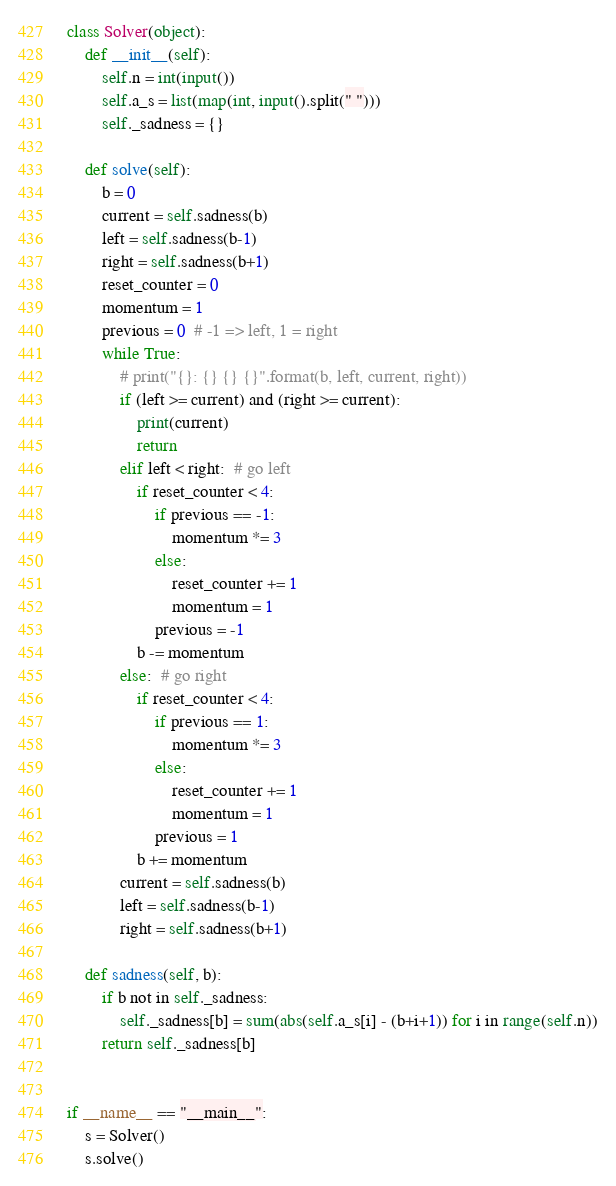Convert code to text. <code><loc_0><loc_0><loc_500><loc_500><_Python_>class Solver(object):
    def __init__(self):
        self.n = int(input())
        self.a_s = list(map(int, input().split(" ")))
        self._sadness = {}

    def solve(self):
        b = 0
        current = self.sadness(b)
        left = self.sadness(b-1)
        right = self.sadness(b+1)
        reset_counter = 0
        momentum = 1
        previous = 0  # -1 => left, 1 = right
        while True:
            # print("{}: {} {} {}".format(b, left, current, right))
            if (left >= current) and (right >= current):
                print(current)
                return
            elif left < right:  # go left
                if reset_counter < 4:
                    if previous == -1:
                        momentum *= 3
                    else:
                        reset_counter += 1
                        momentum = 1
                    previous = -1
                b -= momentum
            else:  # go right
                if reset_counter < 4:
                    if previous == 1:
                        momentum *= 3
                    else:
                        reset_counter += 1
                        momentum = 1
                    previous = 1
                b += momentum
            current = self.sadness(b)
            left = self.sadness(b-1)
            right = self.sadness(b+1)
        
    def sadness(self, b):
        if b not in self._sadness:
            self._sadness[b] = sum(abs(self.a_s[i] - (b+i+1)) for i in range(self.n))
        return self._sadness[b]


if __name__ == "__main__":
    s = Solver()
    s.solve()</code> 